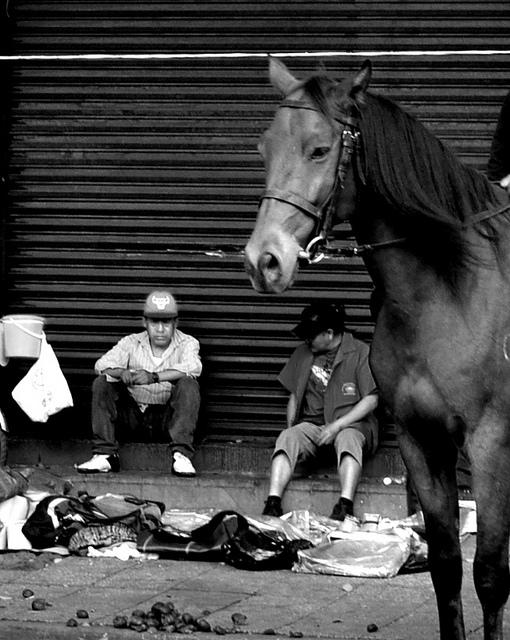Which side of the neck is the horse's mane brushed to?
Answer briefly. Left. Is this in color?
Short answer required. No. Is the horse moving?
Be succinct. No. How many of the horses legs are visible?
Give a very brief answer. 2. 